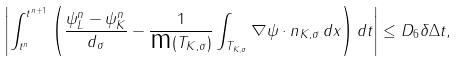<formula> <loc_0><loc_0><loc_500><loc_500>\left | \int _ { t ^ { n } } ^ { t ^ { n + 1 } } \left ( \frac { \psi _ { L } ^ { n } - \psi _ { K } ^ { n } } { d _ { \sigma } } - \frac { 1 } { \text {m} ( T _ { K , \sigma } ) } \int _ { T _ { K , \sigma } } \nabla \psi \cdot n _ { K , \sigma } \, d x \right ) d t \right | \leq D _ { 6 } \delta \Delta t ,</formula> 